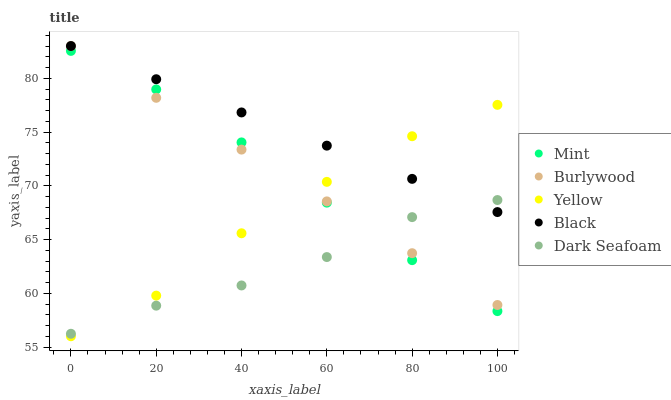Does Dark Seafoam have the minimum area under the curve?
Answer yes or no. Yes. Does Black have the maximum area under the curve?
Answer yes or no. Yes. Does Black have the minimum area under the curve?
Answer yes or no. No. Does Dark Seafoam have the maximum area under the curve?
Answer yes or no. No. Is Black the smoothest?
Answer yes or no. Yes. Is Yellow the roughest?
Answer yes or no. Yes. Is Dark Seafoam the smoothest?
Answer yes or no. No. Is Dark Seafoam the roughest?
Answer yes or no. No. Does Yellow have the lowest value?
Answer yes or no. Yes. Does Dark Seafoam have the lowest value?
Answer yes or no. No. Does Black have the highest value?
Answer yes or no. Yes. Does Dark Seafoam have the highest value?
Answer yes or no. No. Is Mint less than Black?
Answer yes or no. Yes. Is Black greater than Mint?
Answer yes or no. Yes. Does Black intersect Yellow?
Answer yes or no. Yes. Is Black less than Yellow?
Answer yes or no. No. Is Black greater than Yellow?
Answer yes or no. No. Does Mint intersect Black?
Answer yes or no. No. 